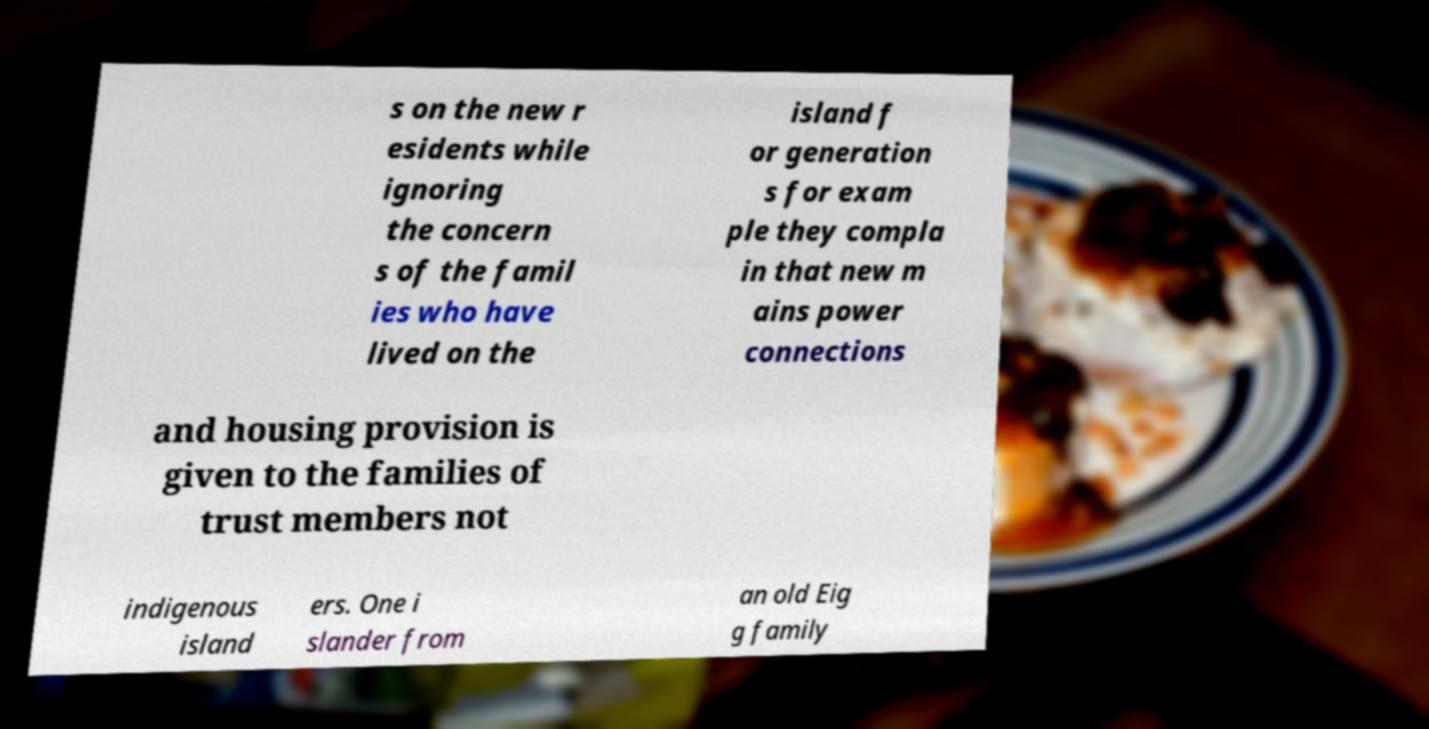Please identify and transcribe the text found in this image. s on the new r esidents while ignoring the concern s of the famil ies who have lived on the island f or generation s for exam ple they compla in that new m ains power connections and housing provision is given to the families of trust members not indigenous island ers. One i slander from an old Eig g family 